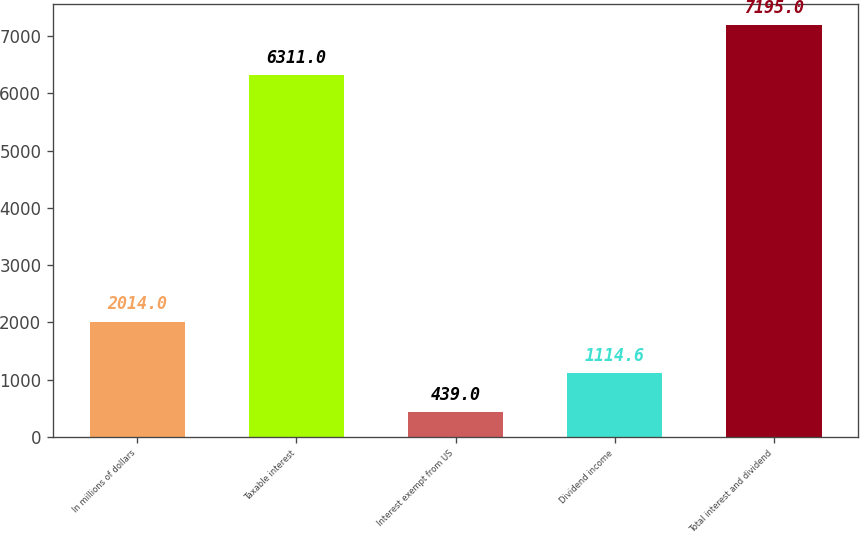Convert chart. <chart><loc_0><loc_0><loc_500><loc_500><bar_chart><fcel>In millions of dollars<fcel>Taxable interest<fcel>Interest exempt from US<fcel>Dividend income<fcel>Total interest and dividend<nl><fcel>2014<fcel>6311<fcel>439<fcel>1114.6<fcel>7195<nl></chart> 